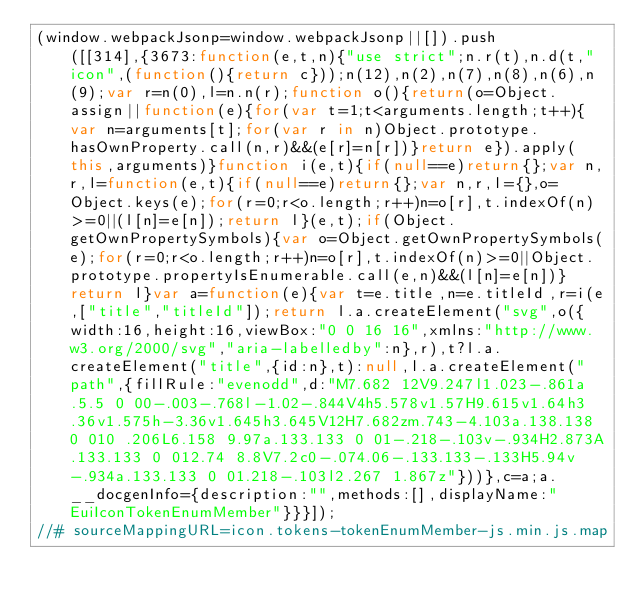<code> <loc_0><loc_0><loc_500><loc_500><_JavaScript_>(window.webpackJsonp=window.webpackJsonp||[]).push([[314],{3673:function(e,t,n){"use strict";n.r(t),n.d(t,"icon",(function(){return c}));n(12),n(2),n(7),n(8),n(6),n(9);var r=n(0),l=n.n(r);function o(){return(o=Object.assign||function(e){for(var t=1;t<arguments.length;t++){var n=arguments[t];for(var r in n)Object.prototype.hasOwnProperty.call(n,r)&&(e[r]=n[r])}return e}).apply(this,arguments)}function i(e,t){if(null==e)return{};var n,r,l=function(e,t){if(null==e)return{};var n,r,l={},o=Object.keys(e);for(r=0;r<o.length;r++)n=o[r],t.indexOf(n)>=0||(l[n]=e[n]);return l}(e,t);if(Object.getOwnPropertySymbols){var o=Object.getOwnPropertySymbols(e);for(r=0;r<o.length;r++)n=o[r],t.indexOf(n)>=0||Object.prototype.propertyIsEnumerable.call(e,n)&&(l[n]=e[n])}return l}var a=function(e){var t=e.title,n=e.titleId,r=i(e,["title","titleId"]);return l.a.createElement("svg",o({width:16,height:16,viewBox:"0 0 16 16",xmlns:"http://www.w3.org/2000/svg","aria-labelledby":n},r),t?l.a.createElement("title",{id:n},t):null,l.a.createElement("path",{fillRule:"evenodd",d:"M7.682 12V9.247l1.023-.861a.5.5 0 00-.003-.768l-1.02-.844V4h5.578v1.57H9.615v1.64h3.36v1.575h-3.36v1.645h3.645V12H7.682zm.743-4.103a.138.138 0 010 .206L6.158 9.97a.133.133 0 01-.218-.103v-.934H2.873A.133.133 0 012.74 8.8V7.2c0-.074.06-.133.133-.133H5.94v-.934a.133.133 0 01.218-.103l2.267 1.867z"}))},c=a;a.__docgenInfo={description:"",methods:[],displayName:"EuiIconTokenEnumMember"}}}]);
//# sourceMappingURL=icon.tokens-tokenEnumMember-js.min.js.map</code> 